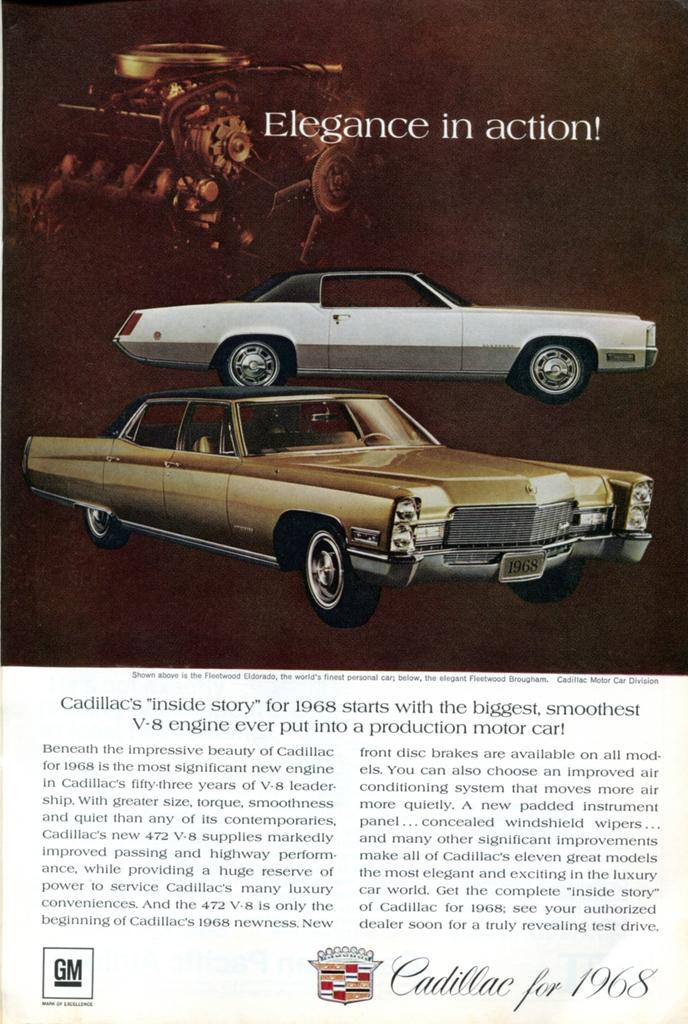What type of medium is the image from? The image is a page from a book. What can be seen in the picture on the page? There are two cars depicted on the page. Is there any text accompanying the image? Yes, there is text written at the bottom of the image. What type of meal is being prepared in the image? There is no meal being prepared in the image; it is a page from a book with two cars depicted. Can you see any rings on the fingers of the people in the image? There are no people or rings present in the image; it is a page from a book with two cars depicted. 